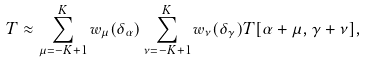Convert formula to latex. <formula><loc_0><loc_0><loc_500><loc_500>T \approx \sum _ { \mu = - K + 1 } ^ { K } w _ { \mu } ( \delta _ { \alpha } ) \sum _ { \nu = - K + 1 } ^ { K } w _ { \nu } ( \delta _ { \gamma } ) T [ \alpha + \mu , \gamma + \nu ] ,</formula> 